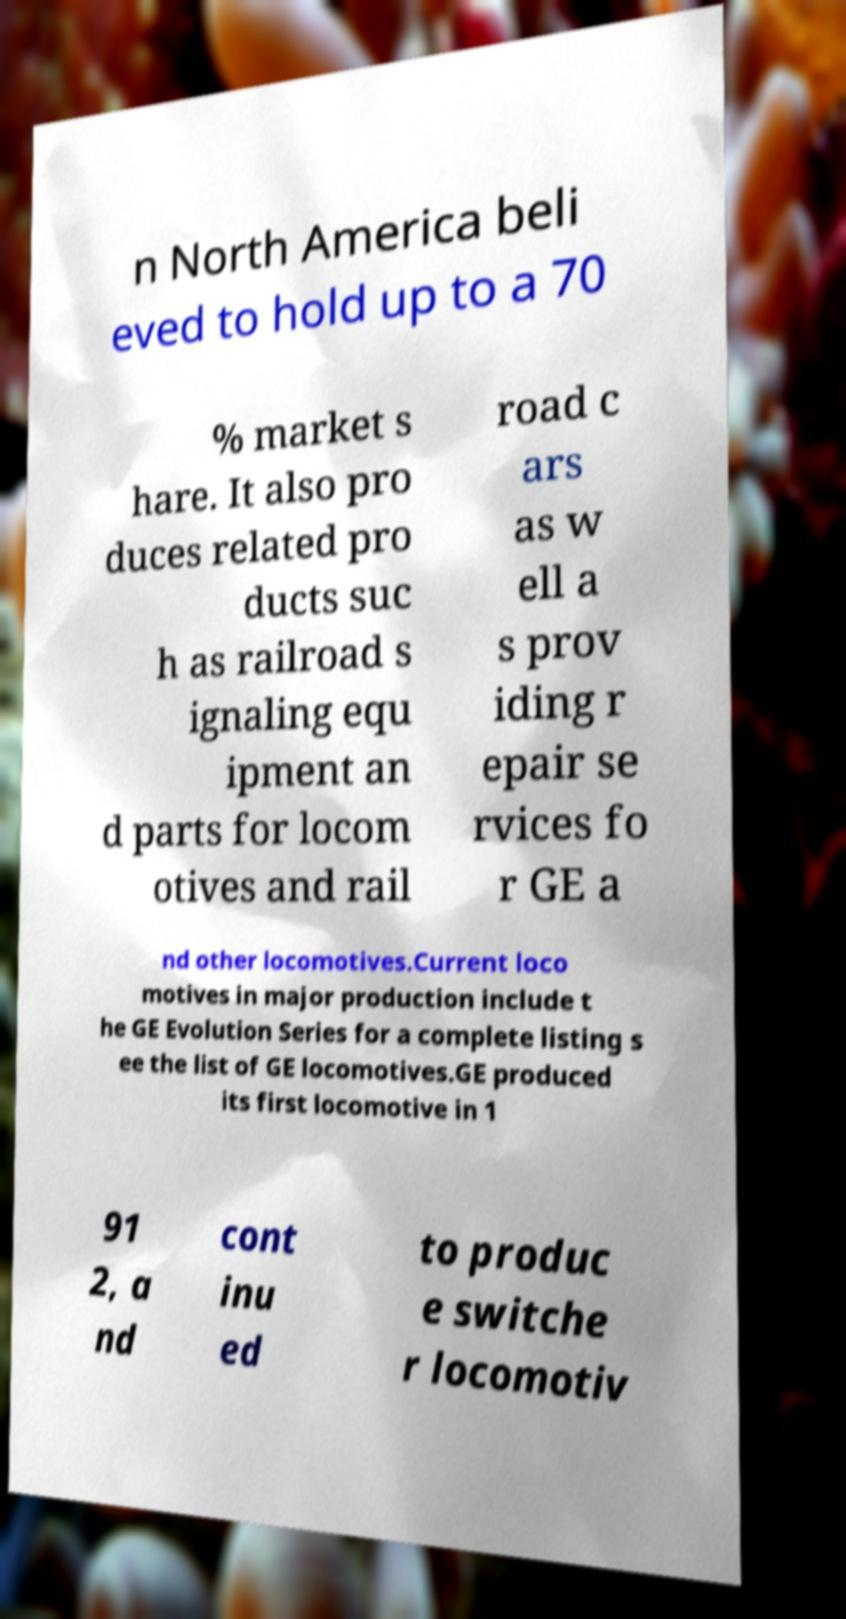There's text embedded in this image that I need extracted. Can you transcribe it verbatim? n North America beli eved to hold up to a 70 % market s hare. It also pro duces related pro ducts suc h as railroad s ignaling equ ipment an d parts for locom otives and rail road c ars as w ell a s prov iding r epair se rvices fo r GE a nd other locomotives.Current loco motives in major production include t he GE Evolution Series for a complete listing s ee the list of GE locomotives.GE produced its first locomotive in 1 91 2, a nd cont inu ed to produc e switche r locomotiv 